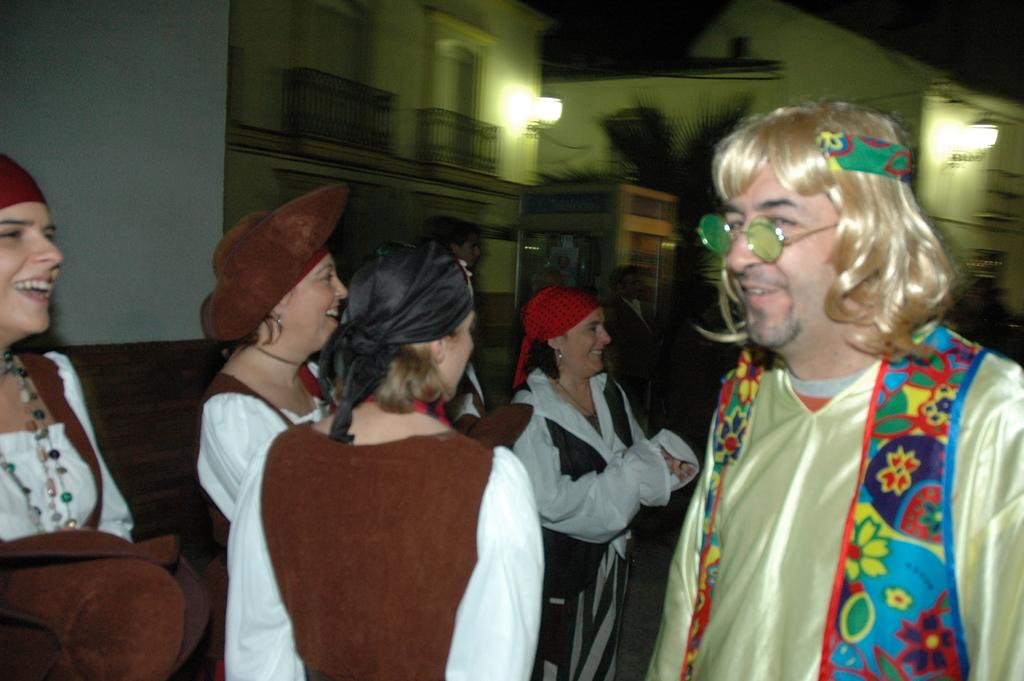How many people are in the image? There are people in the image, but the exact number is not specified. What are the people wearing? The people are wearing clothes. Are there any accessories visible on the people? Yes, some people are wearing caps. What is the general mood of the people in the image? The people are smiling, which suggests a positive or happy mood. What type of structures can be seen in the image? There are buildings in the image. What is the purpose of the fence in the image? The purpose of the fence is not specified, but it could be for enclosing an area or providing a boundary. What type of plant is present in the image? There is a plant in the image, but the specific type is not mentioned. What type of lighting is visible in the image? There are lights in the image, but the specific type or purpose is not specified. How would you describe the sky in the image? The sky is dark in the image, which could indicate nighttime or a cloudy day. What type of cushion is being used to play the game in the image? There is: There is no cushion or game present in the image. 